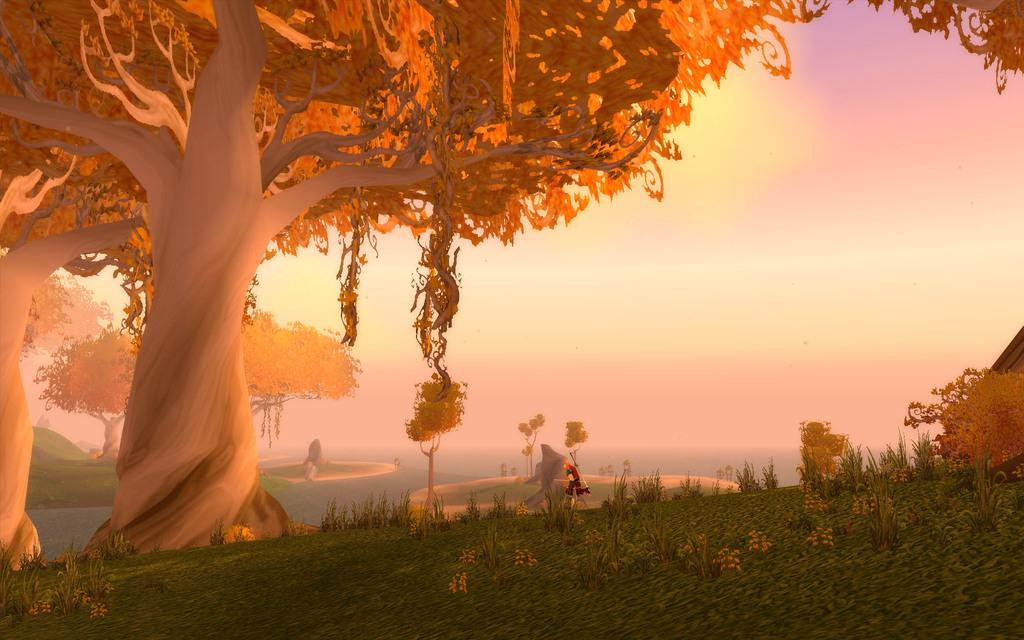What type of picture is the image? The image is an animated picture. What type of environment is depicted in the image? There is grass, plants, and trees in the image, suggesting a natural setting. Are there any living beings in the image? Yes, there is a person in the image. What can be seen in the background of the image? The sky is visible in the background of the image. What type of riddle is the person in the image trying to solve? There is no indication in the image that the person is trying to solve a riddle, so it cannot be determined from the picture. 